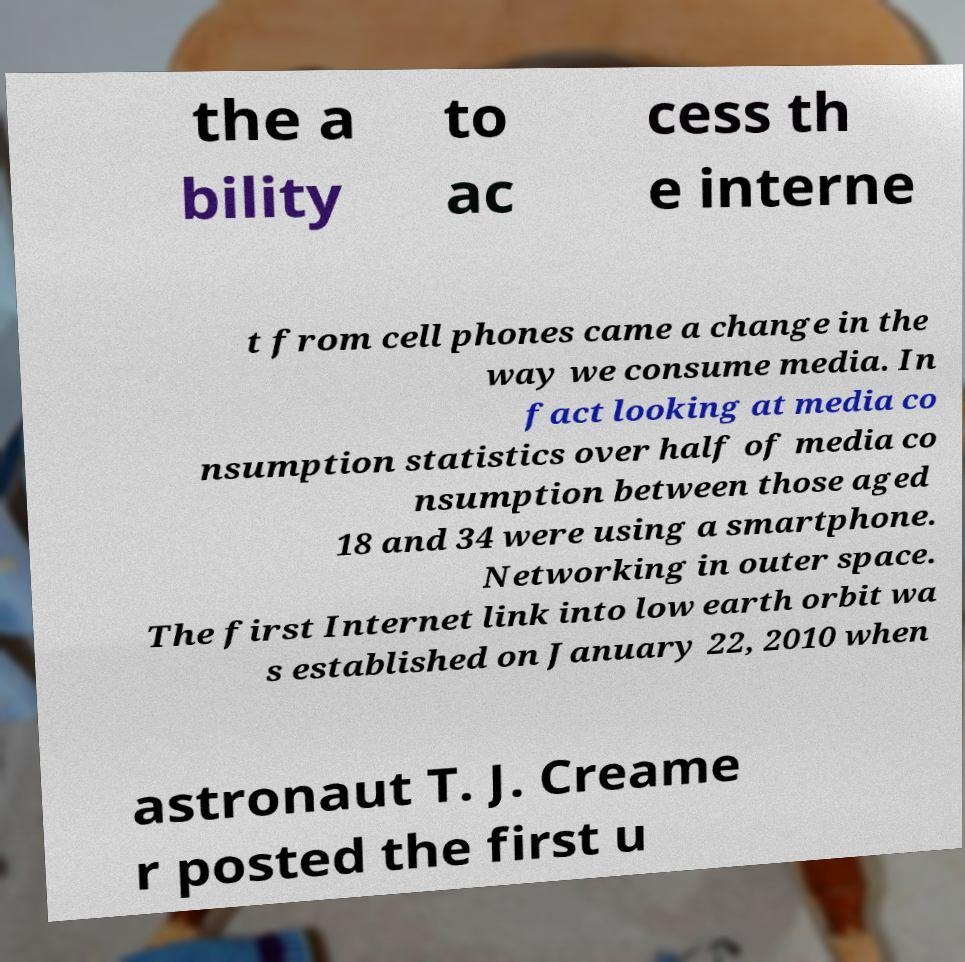Please identify and transcribe the text found in this image. the a bility to ac cess th e interne t from cell phones came a change in the way we consume media. In fact looking at media co nsumption statistics over half of media co nsumption between those aged 18 and 34 were using a smartphone. Networking in outer space. The first Internet link into low earth orbit wa s established on January 22, 2010 when astronaut T. J. Creame r posted the first u 